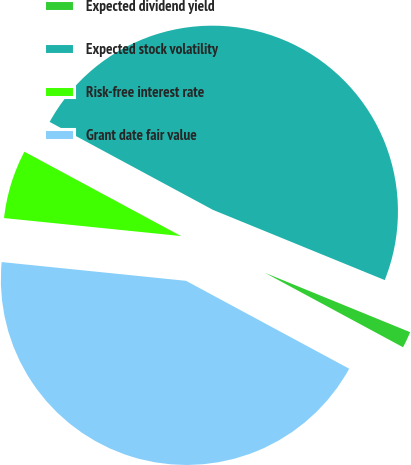Convert chart to OTSL. <chart><loc_0><loc_0><loc_500><loc_500><pie_chart><fcel>Expected dividend yield<fcel>Expected stock volatility<fcel>Risk-free interest rate<fcel>Grant date fair value<nl><fcel>1.69%<fcel>48.31%<fcel>6.25%<fcel>43.75%<nl></chart> 